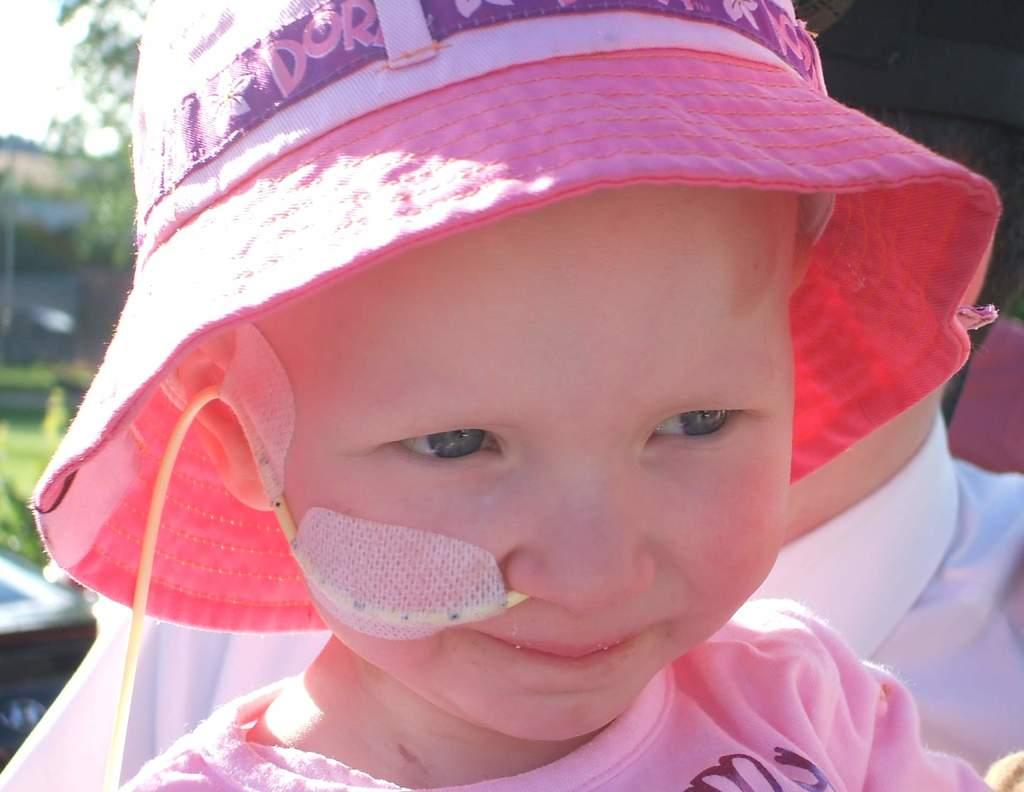Who is present in the image? There is a girl and a man in the image. What is the girl wearing on her head? The girl is wearing a cap. What is unusual about the girl's appearance? There is a pipe in the girl's nostril. What type of vegetation can be seen in the image? There is a tree and grass on the ground in the image. What type of treatment is the girl receiving for her horn in the image? There is no horn present in the image, and therefore no treatment is necessary. What type of flesh can be seen on the tree in the image? There is no flesh visible on the tree in the image; it is a plant, not an animal. 